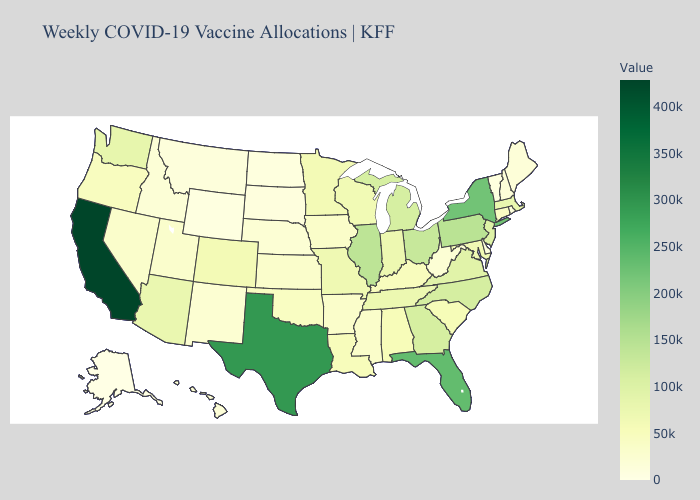Does Idaho have the lowest value in the West?
Concise answer only. No. Does Texas have the highest value in the South?
Give a very brief answer. Yes. Does Alaska have the lowest value in the West?
Give a very brief answer. Yes. Is the legend a continuous bar?
Answer briefly. Yes. Among the states that border Delaware , which have the highest value?
Write a very short answer. Pennsylvania. Does Indiana have the lowest value in the MidWest?
Concise answer only. No. 